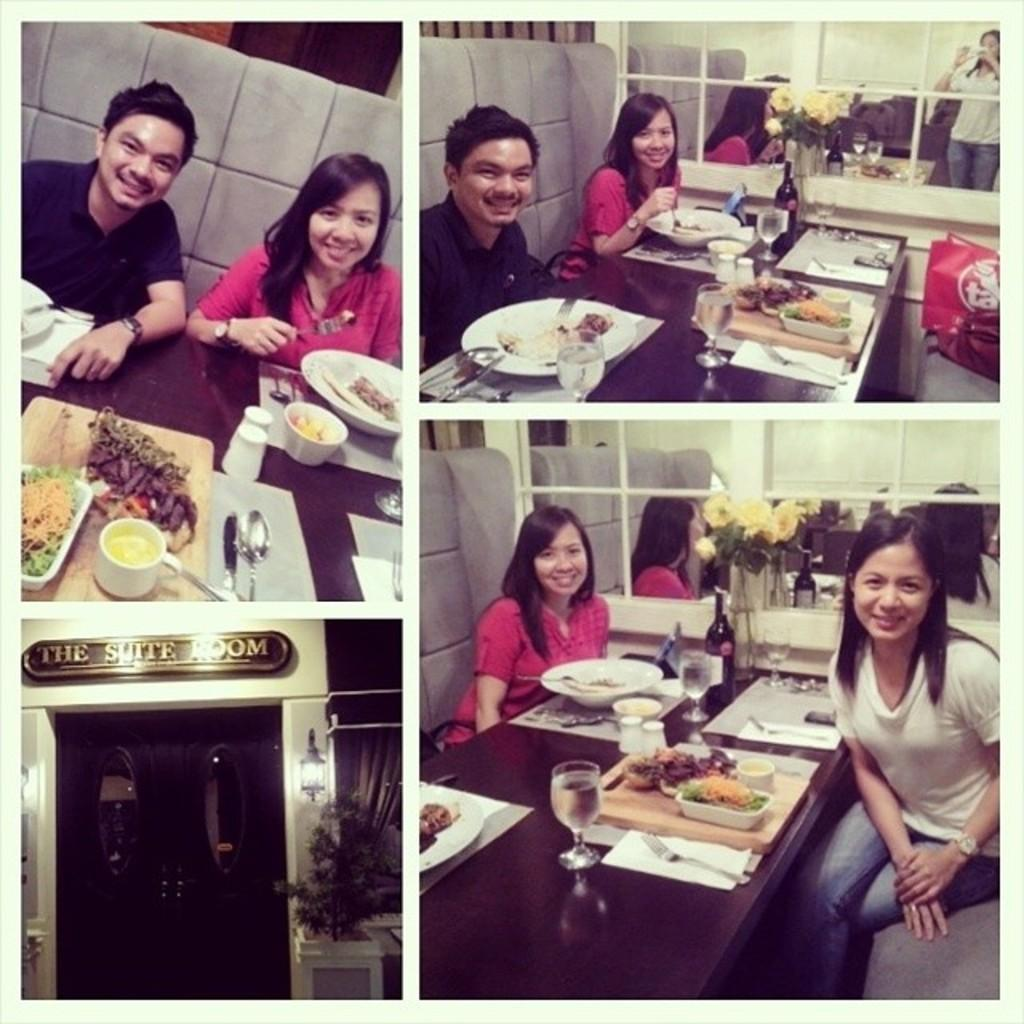What are the people in the image doing? The persons in the image are sitting on chairs. What is present on the table in the image? There is a table in the image with glasses, plates, bowls, food, and a flower vase. What might the people be using the glasses for? The glasses on the table might be used for drinking. What type of decoration is present on the table? There is a flower vase on the table as a decoration. Can you see any signs of a cough in the image? There is no indication of a cough or any health-related issues in the image. Are there any cobwebs visible in the image? There is no mention of cobwebs or any dust or dirt in the image. 